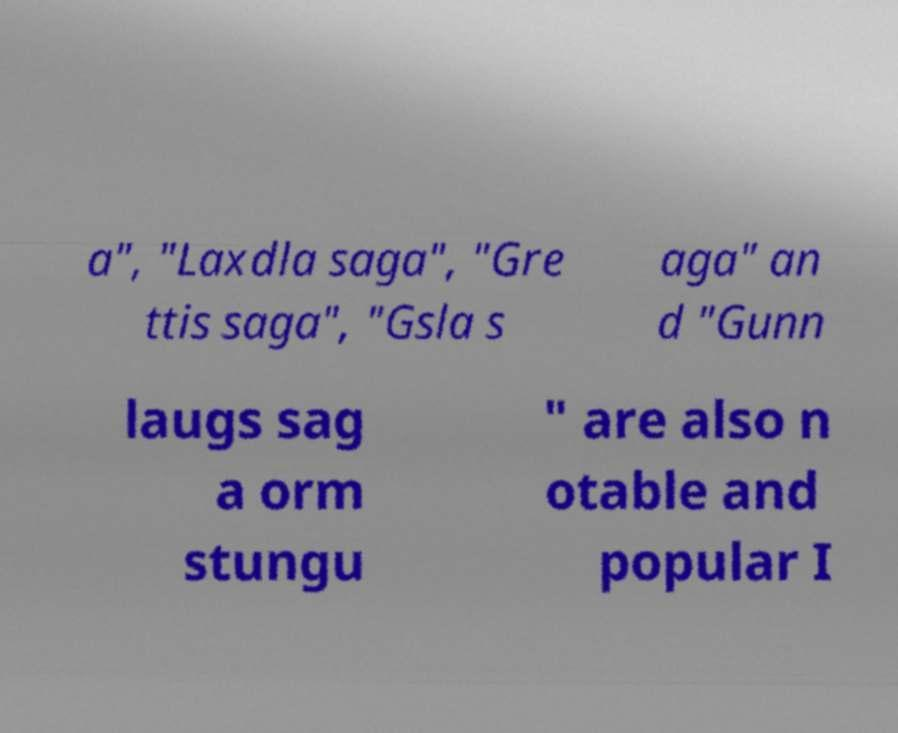For documentation purposes, I need the text within this image transcribed. Could you provide that? a", "Laxdla saga", "Gre ttis saga", "Gsla s aga" an d "Gunn laugs sag a orm stungu " are also n otable and popular I 